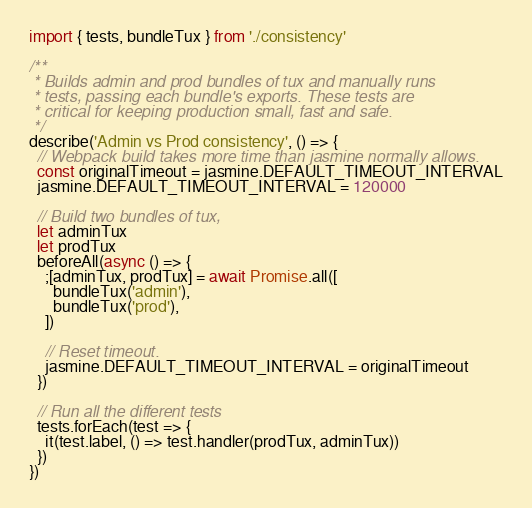<code> <loc_0><loc_0><loc_500><loc_500><_TypeScript_>import { tests, bundleTux } from './consistency'

/**
 * Builds admin and prod bundles of tux and manually runs
 * tests, passing each bundle's exports. These tests are
 * critical for keeping production small, fast and safe.
 */
describe('Admin vs Prod consistency', () => {
  // Webpack build takes more time than jasmine normally allows.
  const originalTimeout = jasmine.DEFAULT_TIMEOUT_INTERVAL
  jasmine.DEFAULT_TIMEOUT_INTERVAL = 120000

  // Build two bundles of tux,
  let adminTux
  let prodTux
  beforeAll(async () => {
    ;[adminTux, prodTux] = await Promise.all([
      bundleTux('admin'),
      bundleTux('prod'),
    ])

    // Reset timeout.
    jasmine.DEFAULT_TIMEOUT_INTERVAL = originalTimeout
  })

  // Run all the different tests
  tests.forEach(test => {
    it(test.label, () => test.handler(prodTux, adminTux))
  })
})
</code> 